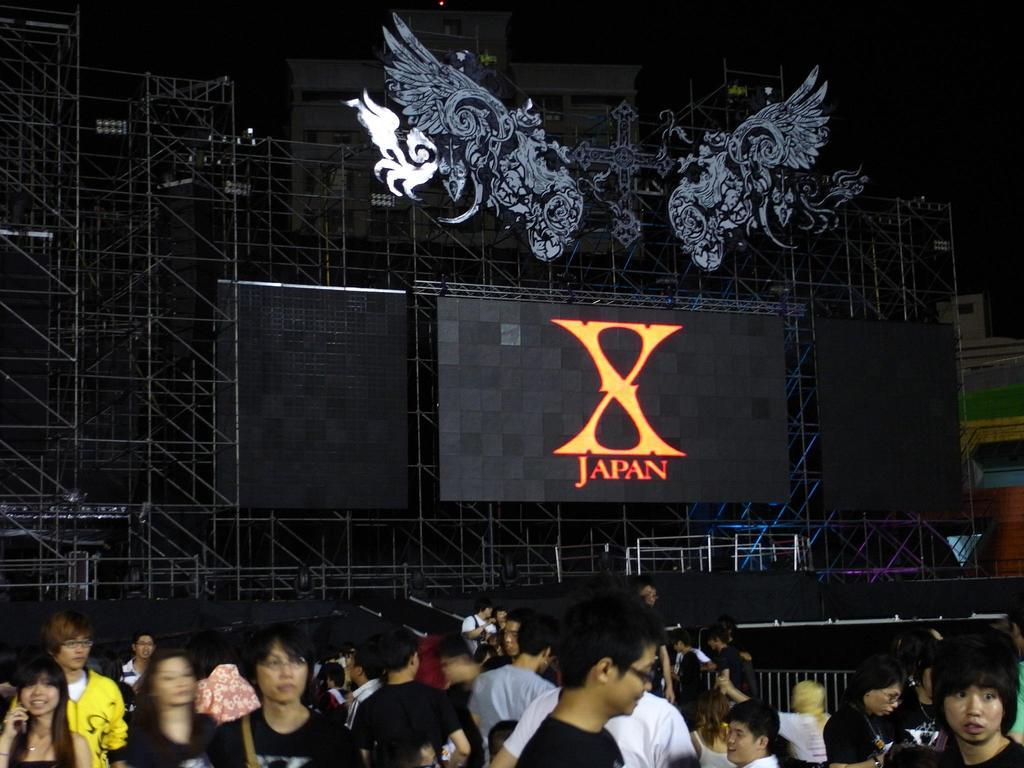What is located in the center of the image? There are speakers and a screen on stands in the center of the image. What can be seen on the screen in the image? The content on the screen is not visible from the provided facts. Who or what is at the bottom of the image? There are people at the bottom of the image. What is visible in the background of the image? There are buildings and the sky in the background of the image. What type of wound can be seen on the screen in the image? There is no wound visible on the screen in the image, as the content on the screen is not described in the provided facts. 